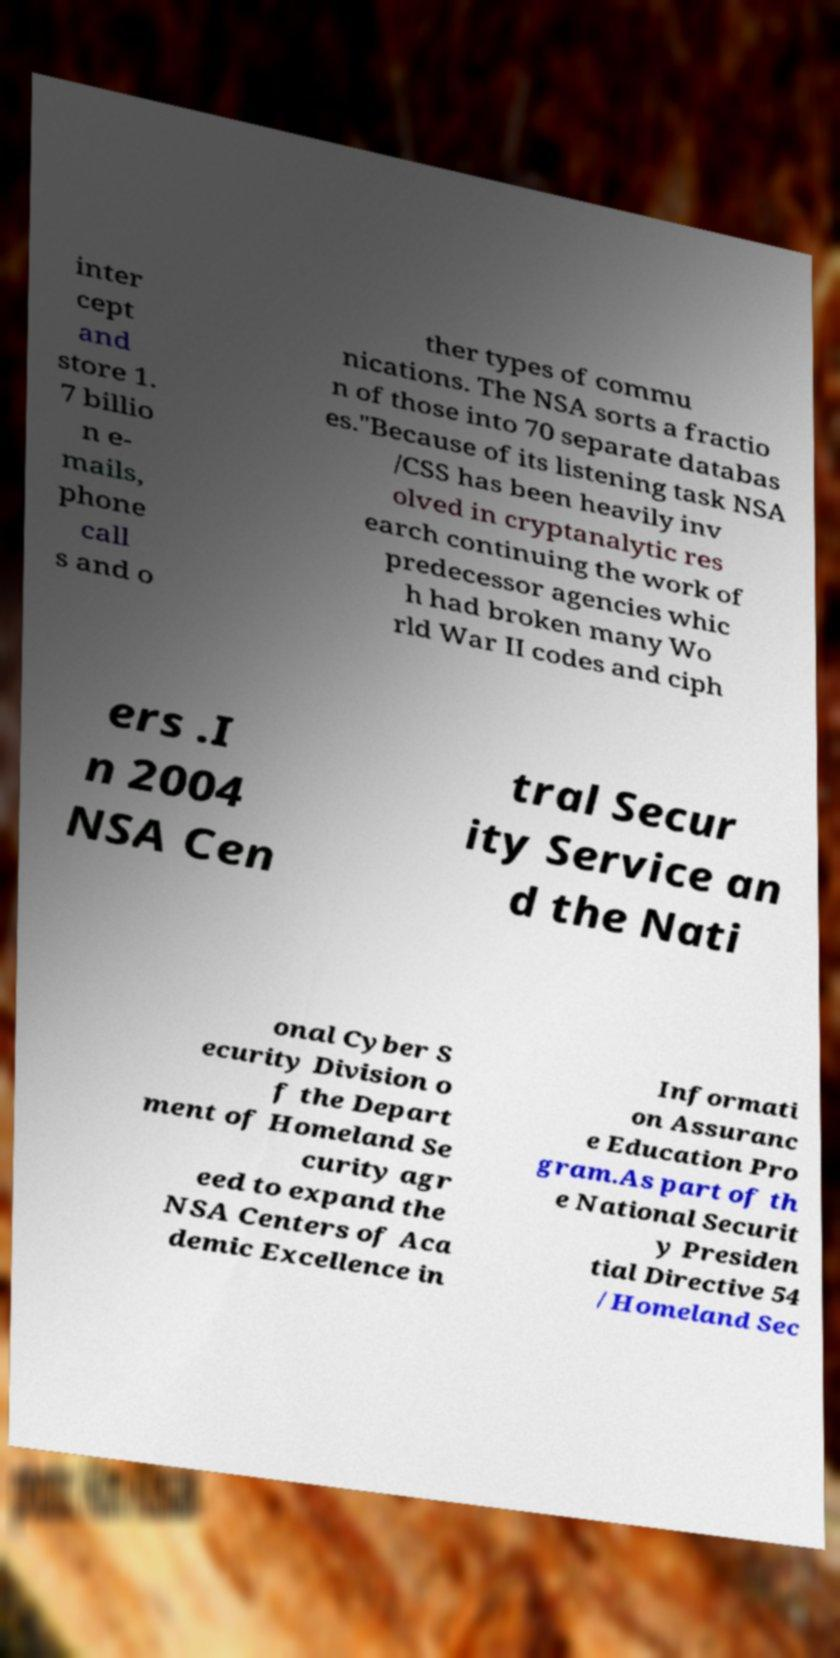I need the written content from this picture converted into text. Can you do that? inter cept and store 1. 7 billio n e- mails, phone call s and o ther types of commu nications. The NSA sorts a fractio n of those into 70 separate databas es."Because of its listening task NSA /CSS has been heavily inv olved in cryptanalytic res earch continuing the work of predecessor agencies whic h had broken many Wo rld War II codes and ciph ers .I n 2004 NSA Cen tral Secur ity Service an d the Nati onal Cyber S ecurity Division o f the Depart ment of Homeland Se curity agr eed to expand the NSA Centers of Aca demic Excellence in Informati on Assuranc e Education Pro gram.As part of th e National Securit y Presiden tial Directive 54 /Homeland Sec 